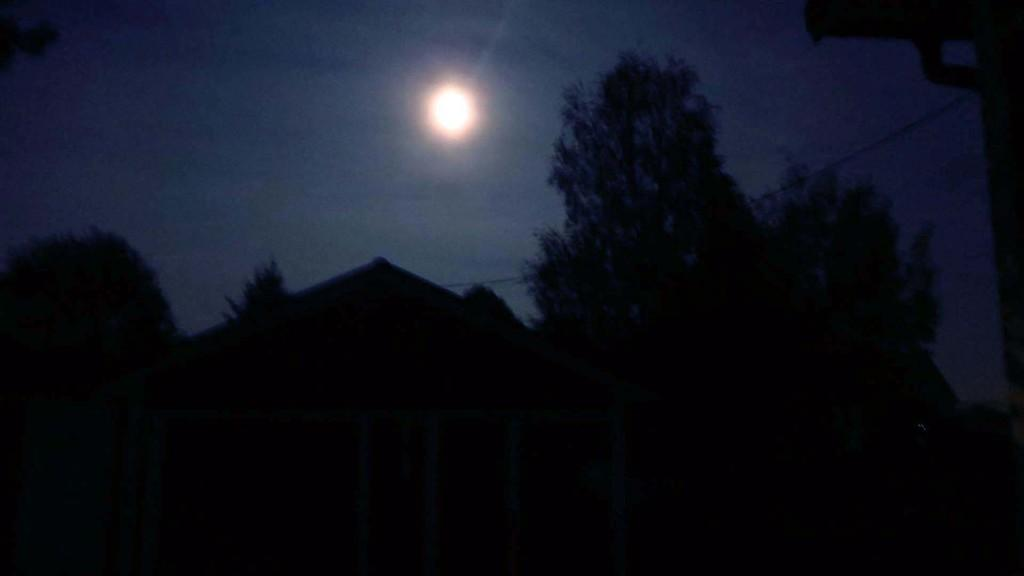What type of vegetation is on the right side of the image? There are trees on the right side of the image. What celestial body is visible in the middle of the image? There is a sun in the middle of the image. How many kittens are playing with a record on the left side of the image? There are no kittens or records present in the image. 